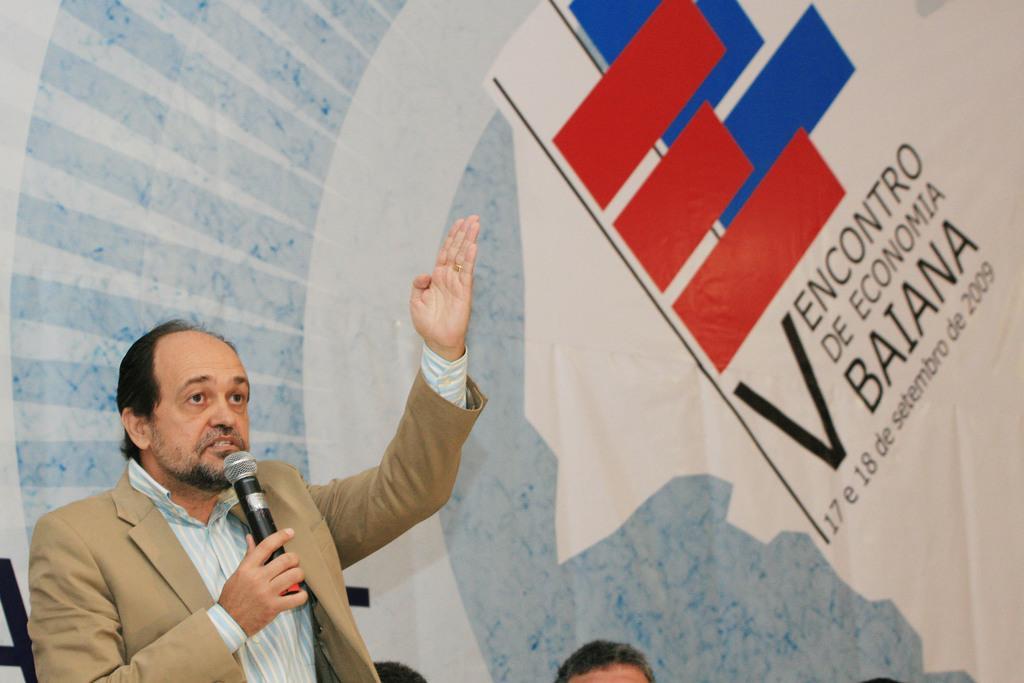Please provide a concise description of this image. On the left side of this image I can see a man wearing a suit, holding a mike in the hand and speaking. At the bottom of the image I can see few persons heads. In the background there is a banner on which I can see some text. 